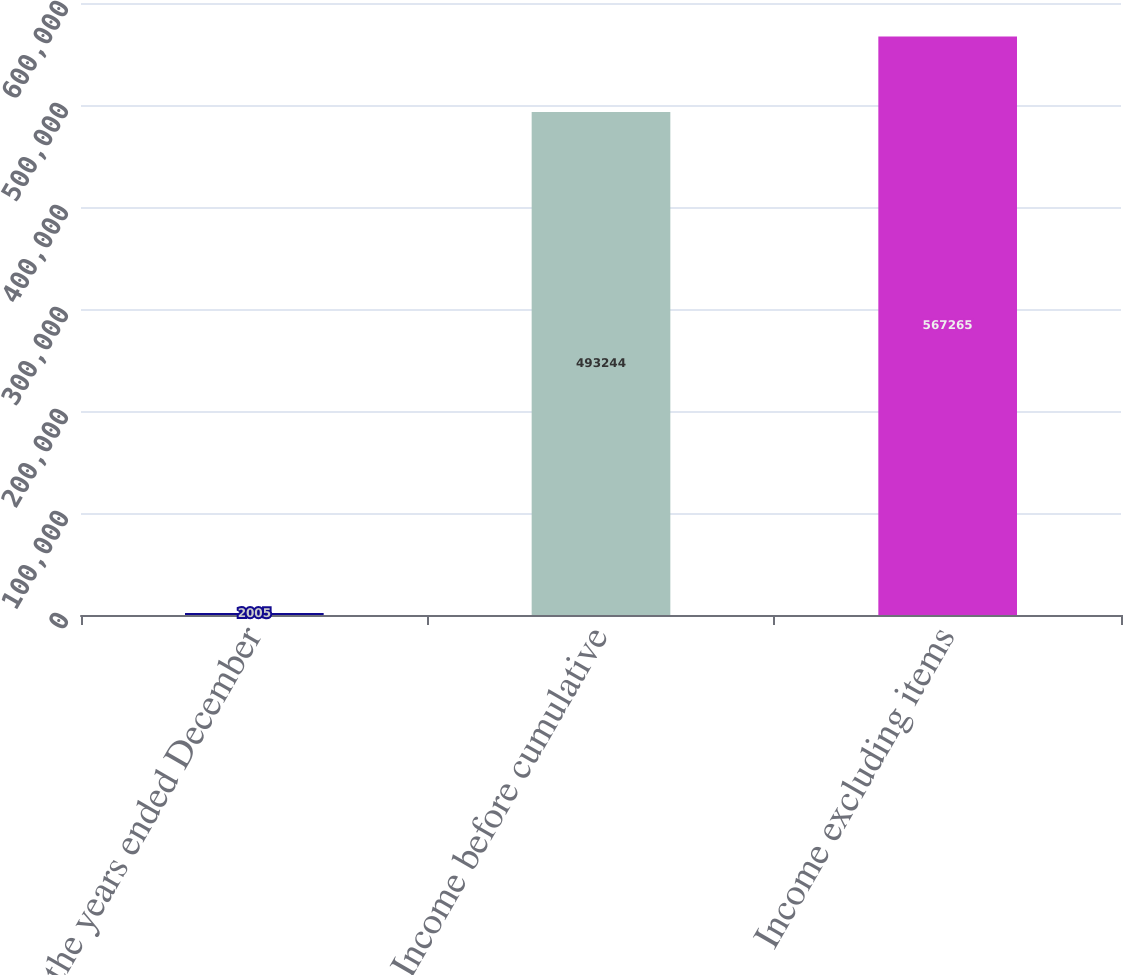Convert chart to OTSL. <chart><loc_0><loc_0><loc_500><loc_500><bar_chart><fcel>For the years ended December<fcel>Income before cumulative<fcel>Income excluding items<nl><fcel>2005<fcel>493244<fcel>567265<nl></chart> 